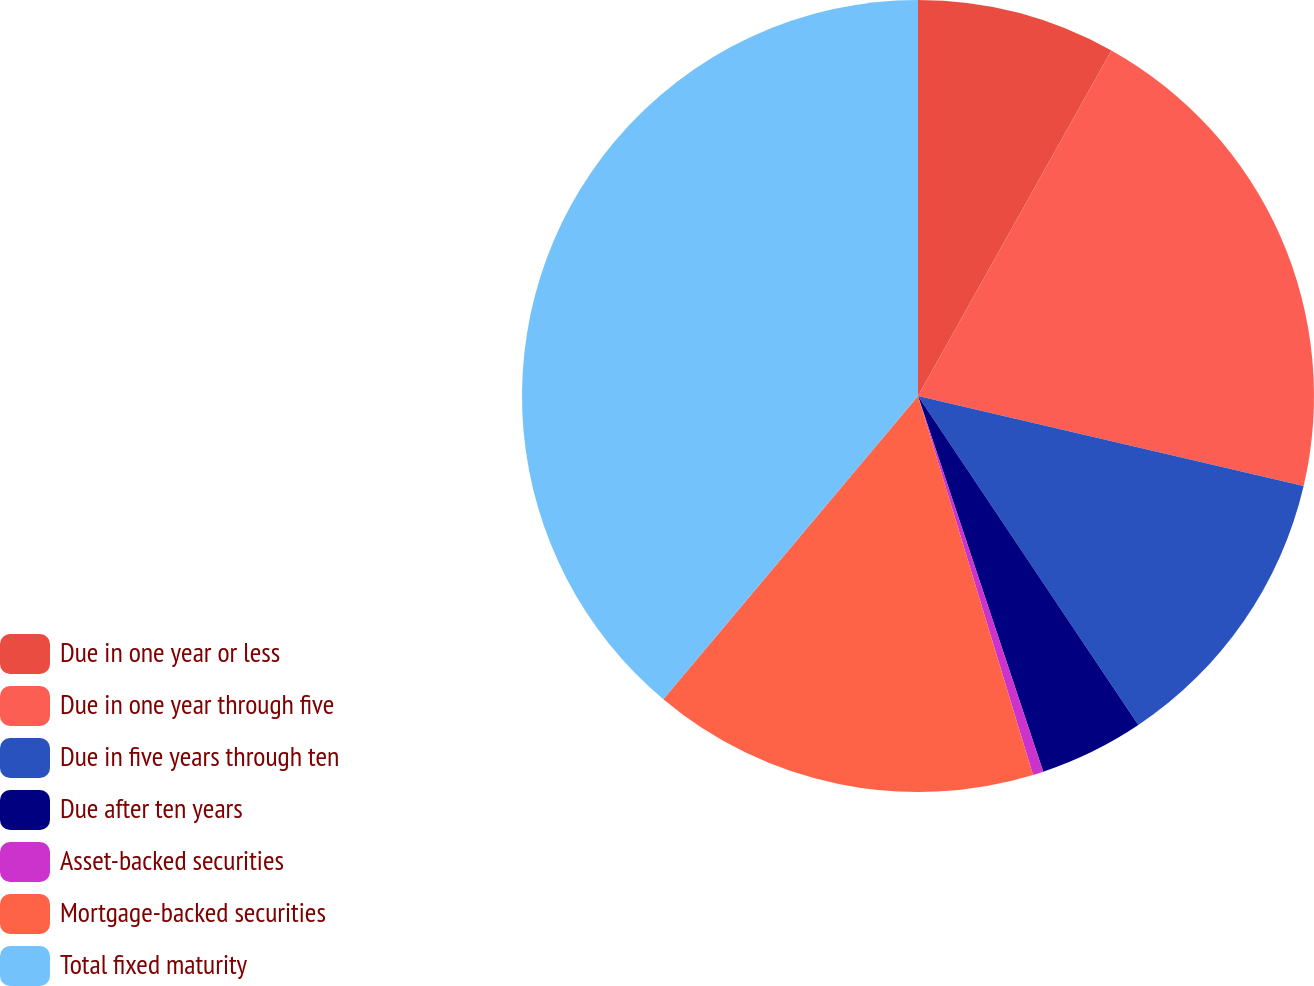<chart> <loc_0><loc_0><loc_500><loc_500><pie_chart><fcel>Due in one year or less<fcel>Due in one year through five<fcel>Due in five years through ten<fcel>Due after ten years<fcel>Asset-backed securities<fcel>Mortgage-backed securities<fcel>Total fixed maturity<nl><fcel>8.12%<fcel>20.53%<fcel>11.96%<fcel>4.27%<fcel>0.43%<fcel>15.81%<fcel>38.88%<nl></chart> 